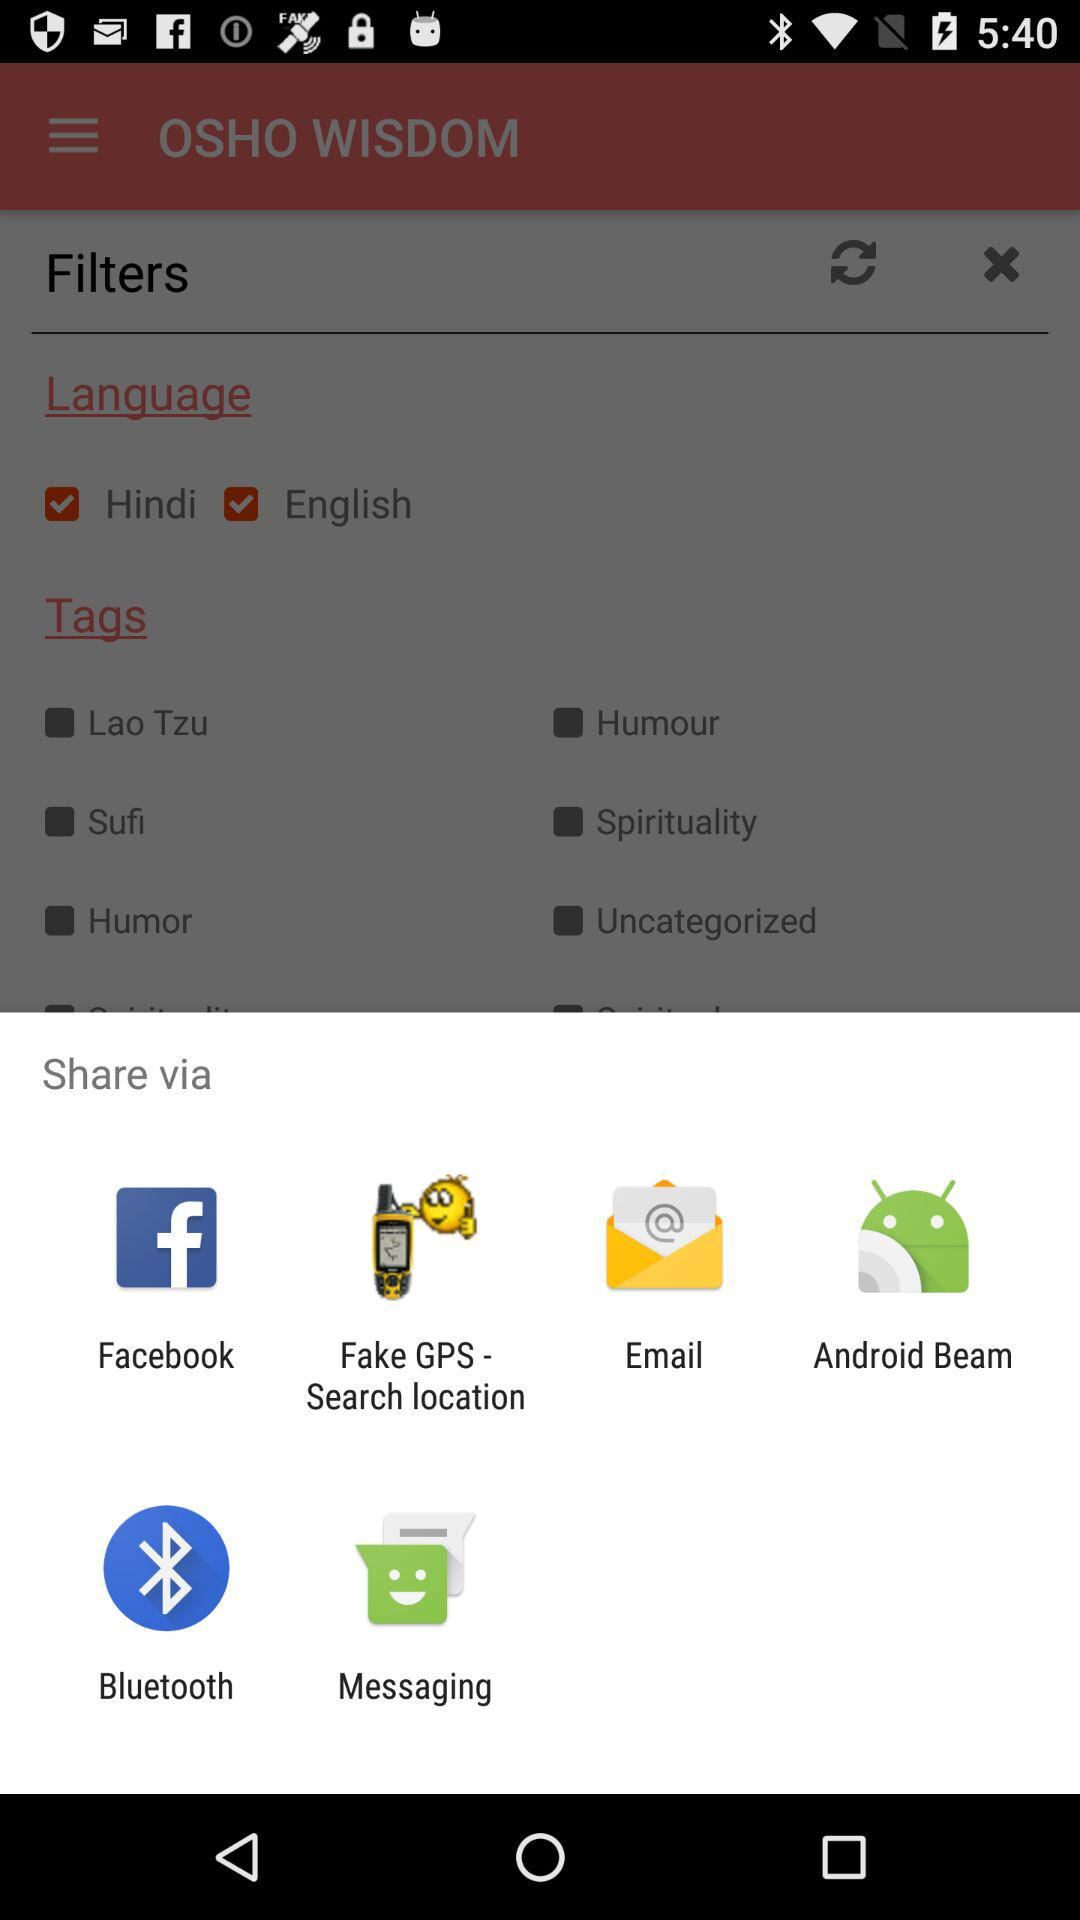Which applications can be used to share? The applications that can be used to share are "Facebook", "Fake GPS - Search location", "Email", "Android Beam", "Bluetooth" and "Messaging". 